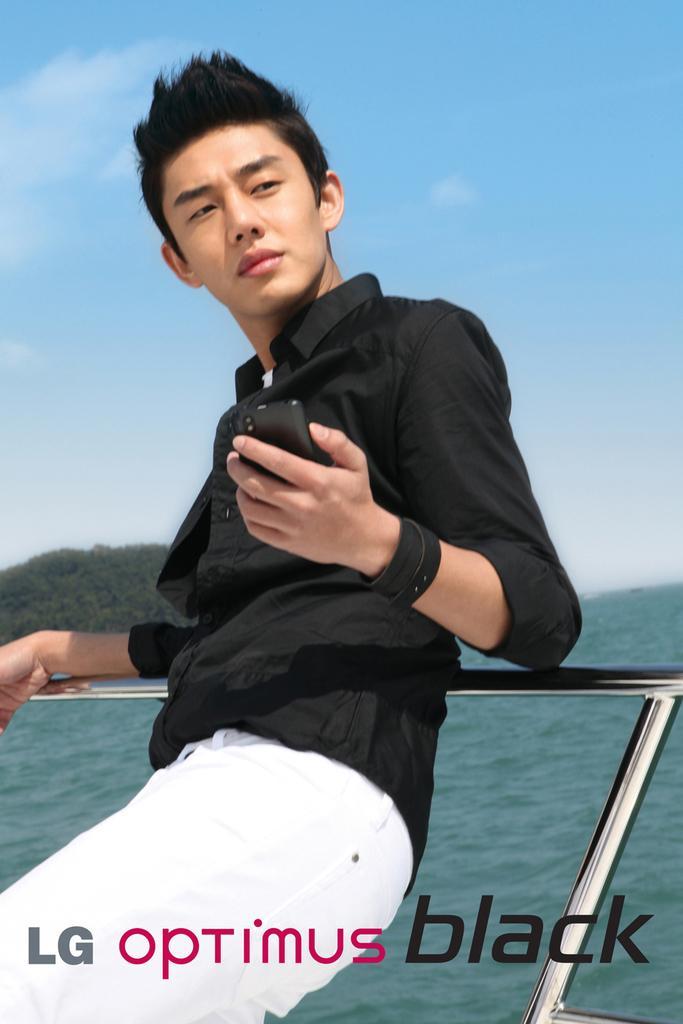Can you describe this image briefly? In the center of the image, we can see a person holding a mobile and in the background, there are trees and hills and we can see rods. At the top, there is sky and at the bottom, there is water and we can see some text. 